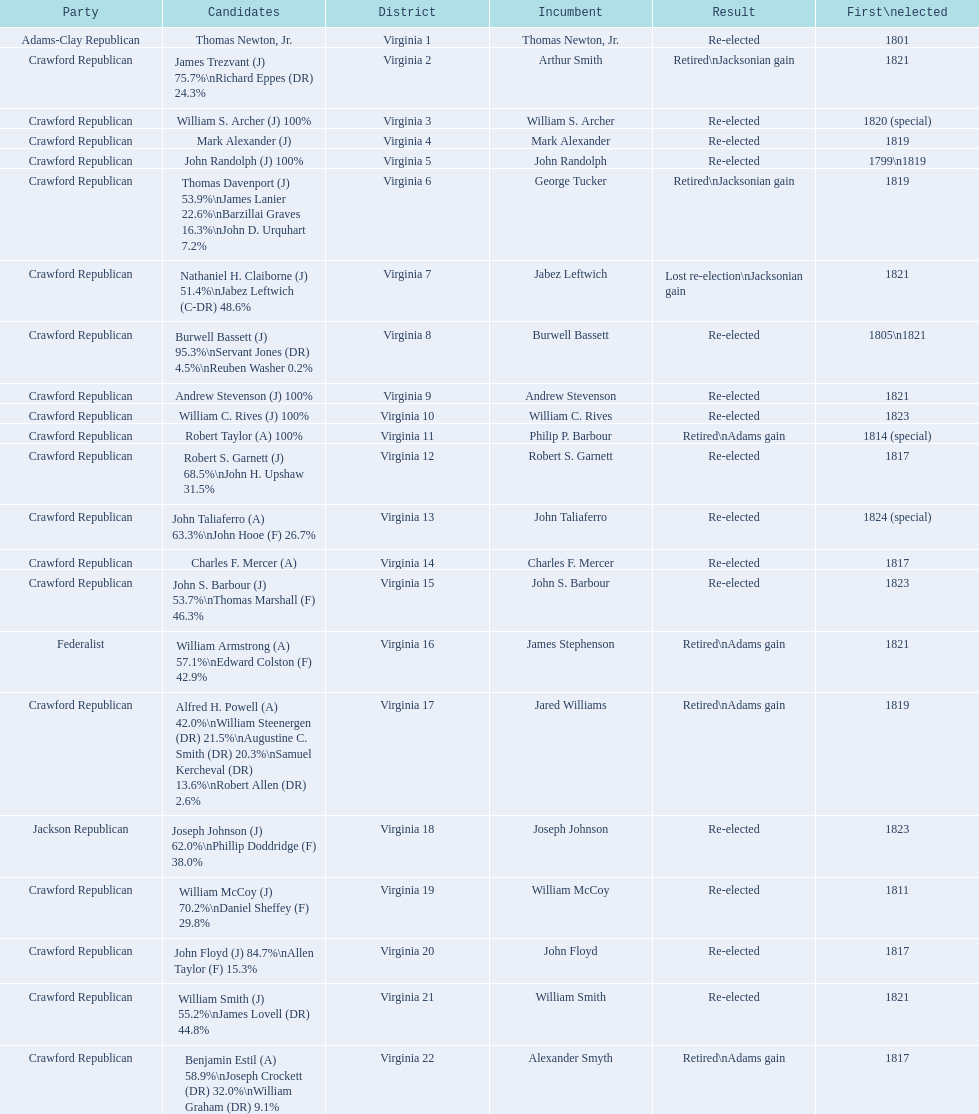Which incumbents belonged to the crawford republican party? Arthur Smith, William S. Archer, Mark Alexander, John Randolph, George Tucker, Jabez Leftwich, Burwell Bassett, Andrew Stevenson, William C. Rives, Philip P. Barbour, Robert S. Garnett, John Taliaferro, Charles F. Mercer, John S. Barbour, Jared Williams, William McCoy, John Floyd, William Smith, Alexander Smyth. Which of these incumbents were first elected in 1821? Arthur Smith, Jabez Leftwich, Andrew Stevenson, William Smith. Which of these incumbents have a last name of smith? Arthur Smith, William Smith. Which of these two were not re-elected? Arthur Smith. 